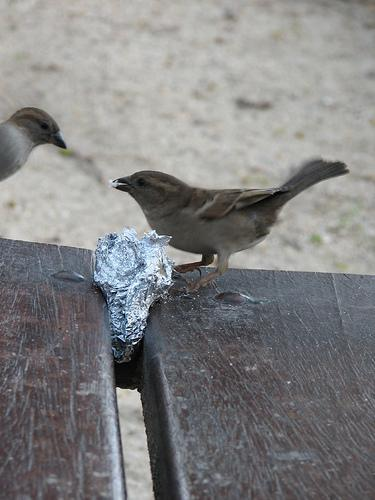Describe the key components of the scene and their relationship within the image. Two birds, one with a piece of aluminum foil in its beak, are competing for food on a cracked and weathered park table, which has a metal screw and some discarded trash on it. In one sentence, describe the interaction between the main subjects in the image. A small brown bird with aluminum foil in its beak confronts a large bully bird on a weathered park bench, competing for food. Give a brief account of the primary subjects and their surroundings in the image. A brown bird with a tan underbelly grasps a piece of aluminum foil with its black beak as it stands on a weathered park bench with another small brown bird nearby. Explain the primary interaction between two subjects in the image. A brown bird with a tan underbelly is defending a piece of aluminum foil from another small brown bird while standing on a weathered park bench. Mention the primary focus in the image along with the object it interacts with. A small brown bird with a tan underbelly has a piece of aluminum foil in its beak while standing on a weathered park bench. Highlight the main subjects in the image and their interaction with each other. Two birds, one with a black beak and an aluminum foil in its mouth, stand on a wooden park bench as they compete for the discarded food. Write a concise description of the main subject and its surrounding elements. A brown bird with a tan underbelly is holding a piece of aluminum foil in its black beak, standing on a weathered park bench, while another small brown bird looks on. Summarize the scenario depicted in the image with specific details. A small bird with a black beak holds aluminum foil on a weathered bench while a bigger bully bird with round black eyes moves in on the discarded food. List the main components of the image and their relationship with each other. Two birds, weathered park bench, aluminum foil, competing for food, discarded trash, cracked picnic table, metal screw. Provide a brief overview of the key elements and interaction between them in the image. Two birds, one mostly brown with a tan underbelly and another small brown bird, are competing for food on a cracked and weathered picnic table with aluminum foil and a metal screw. Can you try finding a completely white bird with blue eyes in the scene? There is no mention of any white bird or blue eyes in the given image information, so this instruction is misleading. What is the name of the park where this scene takes place? No information is provided about the park's name in the given image information. Don't forget to check the bright purple umbrella over the picnic table! There is no mention of any bright purple umbrella or any object related to an umbrella in the given image information, making this instruction misleading. Please identify the highly polished silverware on the table. There is no mention of any silverware in the image information, making this instruction misleading. What do you think about the graffiti on the bench? There is no mention of graffiti in the given image information, making this an invalid instruction for the image. Don't miss the delicious looking cupcakes on the table! There is no mention of any cupcakes in the image information, making this instruction misleading. Did you notice the large green tree next to the birds? There is no mention of any tree, let alone a green one, in the image information. Is there a metallic trash bin near the bench? There is no mention of any metallic trash bin in the given information. Is the bench surrounded by beautiful flowers and well-maintained grass? There are no flowers or well-maintained grass mentioned in the image information. The only ground reference is "brown kind of sandy ground." Can you locate the orange cotton tablecloth on the picnic table? There's no mention of an orange cotton tablecloth in the given information. 